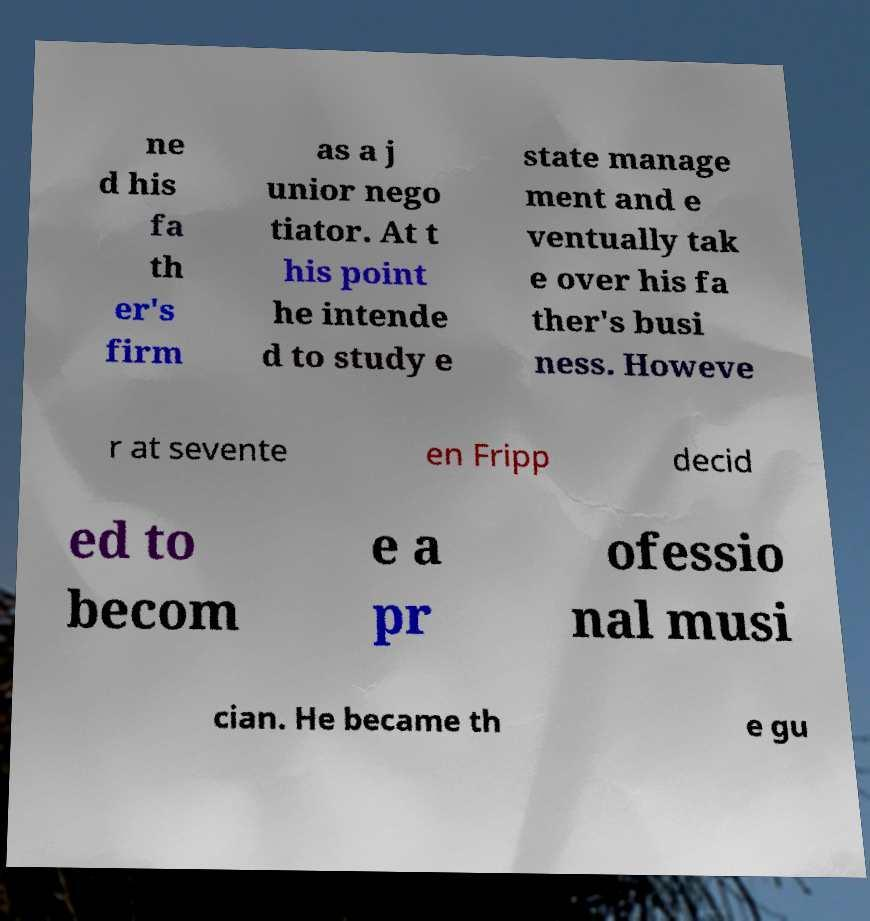Please read and relay the text visible in this image. What does it say? ne d his fa th er's firm as a j unior nego tiator. At t his point he intende d to study e state manage ment and e ventually tak e over his fa ther's busi ness. Howeve r at sevente en Fripp decid ed to becom e a pr ofessio nal musi cian. He became th e gu 